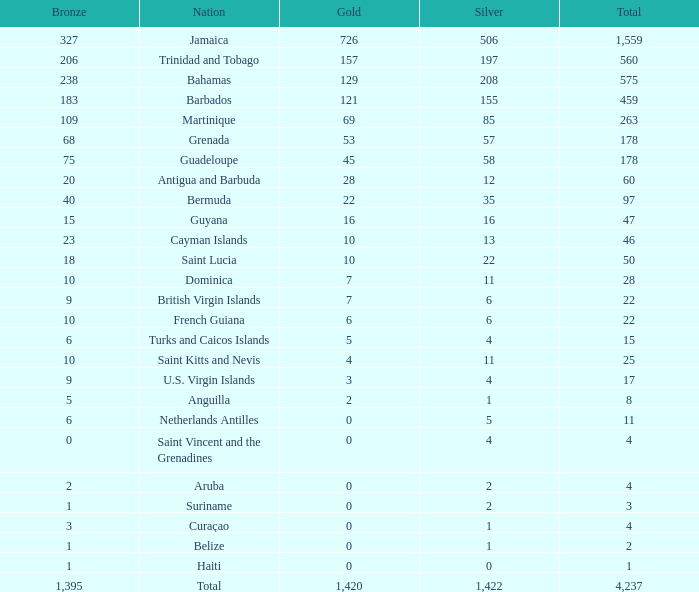What's the total number of Silver that has Gold that's larger than 0, Bronze that's smaller than 23, a Total that's larger than 22, and has the Nation of Saint Kitts and Nevis? 1.0. 